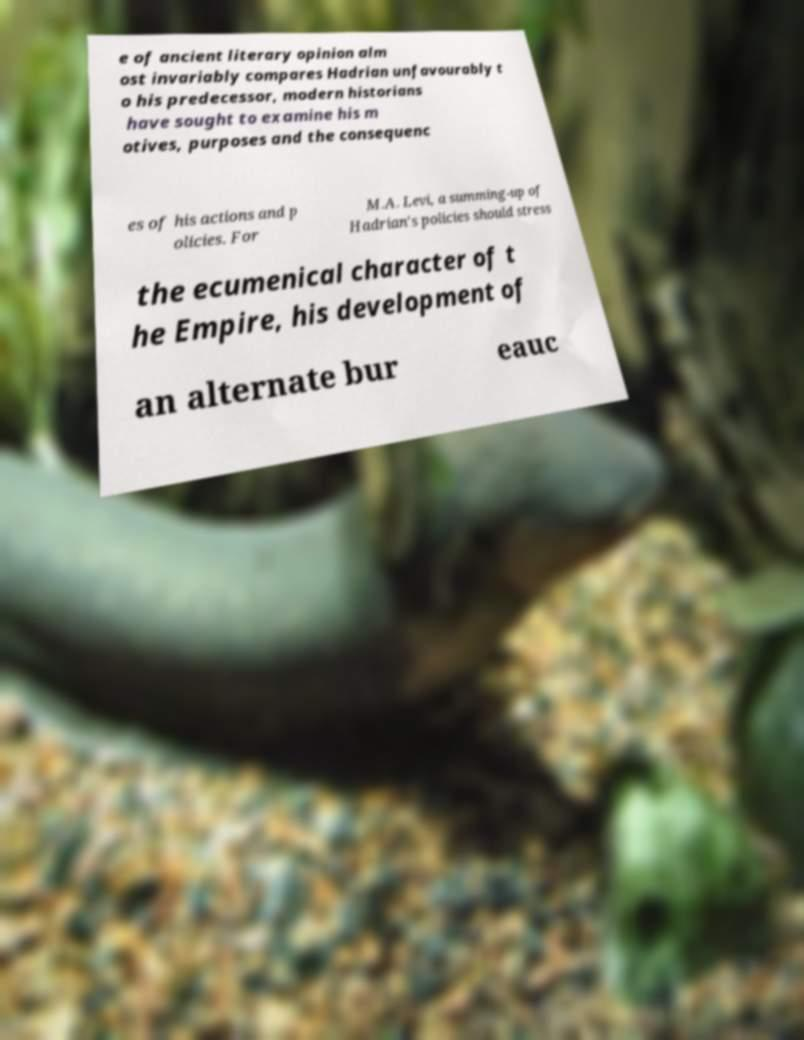Please identify and transcribe the text found in this image. e of ancient literary opinion alm ost invariably compares Hadrian unfavourably t o his predecessor, modern historians have sought to examine his m otives, purposes and the consequenc es of his actions and p olicies. For M.A. Levi, a summing-up of Hadrian's policies should stress the ecumenical character of t he Empire, his development of an alternate bur eauc 